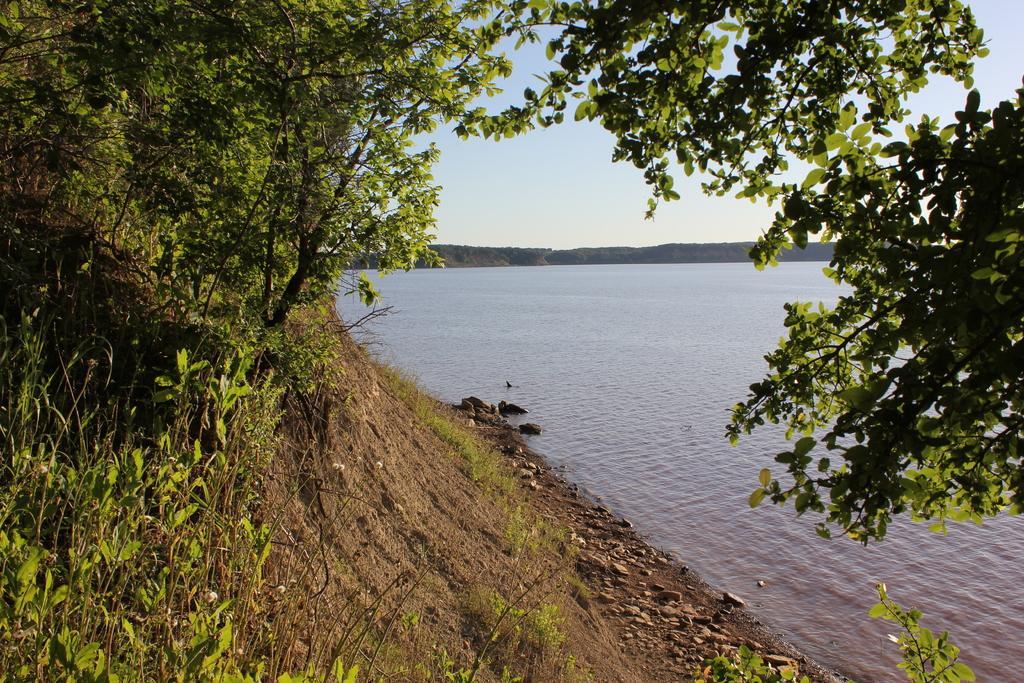Please provide a concise description of this image. This image is taken outdoors. At the top of the image there is the sky. In the background there are many trees. On the right side of the image there is a pond with water. On the left side of the image there are many trees and plants with leaves, stems and branches. There is a ground with grass and pebbles on it. 